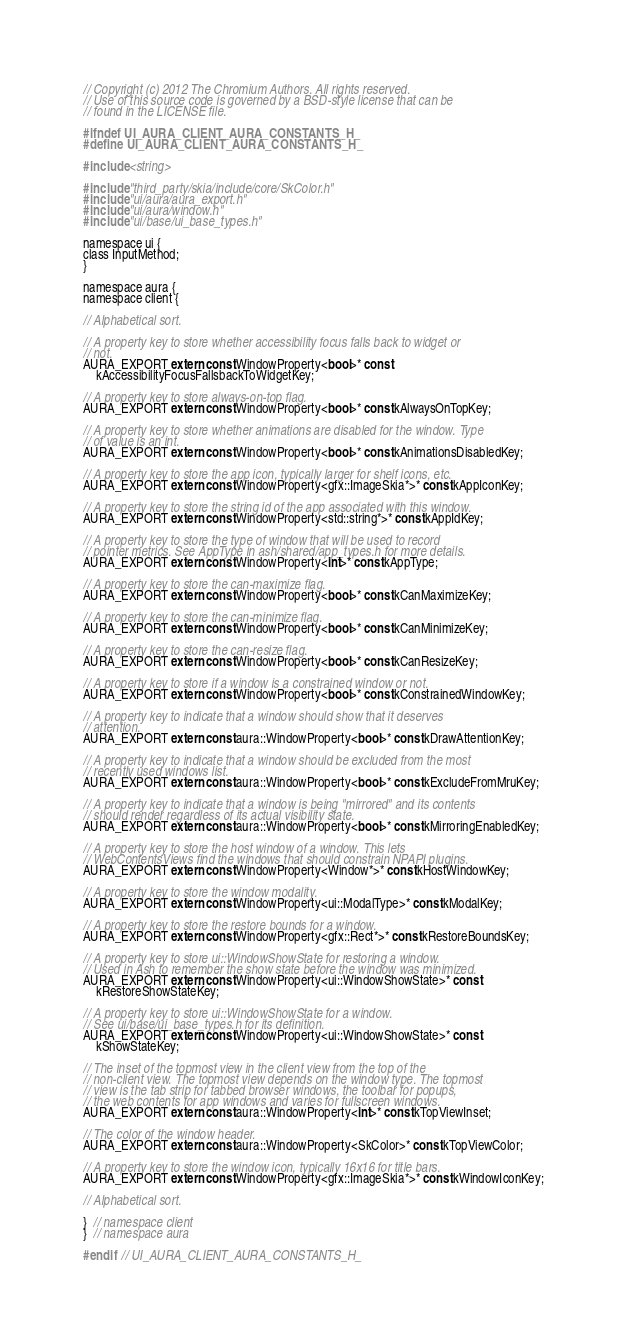<code> <loc_0><loc_0><loc_500><loc_500><_C_>// Copyright (c) 2012 The Chromium Authors. All rights reserved.
// Use of this source code is governed by a BSD-style license that can be
// found in the LICENSE file.

#ifndef UI_AURA_CLIENT_AURA_CONSTANTS_H_
#define UI_AURA_CLIENT_AURA_CONSTANTS_H_

#include <string>

#include "third_party/skia/include/core/SkColor.h"
#include "ui/aura/aura_export.h"
#include "ui/aura/window.h"
#include "ui/base/ui_base_types.h"

namespace ui {
class InputMethod;
}

namespace aura {
namespace client {

// Alphabetical sort.

// A property key to store whether accessibility focus falls back to widget or
// not.
AURA_EXPORT extern const WindowProperty<bool>* const
    kAccessibilityFocusFallsbackToWidgetKey;

// A property key to store always-on-top flag.
AURA_EXPORT extern const WindowProperty<bool>* const kAlwaysOnTopKey;

// A property key to store whether animations are disabled for the window. Type
// of value is an int.
AURA_EXPORT extern const WindowProperty<bool>* const kAnimationsDisabledKey;

// A property key to store the app icon, typically larger for shelf icons, etc.
AURA_EXPORT extern const WindowProperty<gfx::ImageSkia*>* const kAppIconKey;

// A property key to store the string id of the app associated with this window.
AURA_EXPORT extern const WindowProperty<std::string*>* const kAppIdKey;

// A property key to store the type of window that will be used to record
// pointer metrics. See AppType in ash/shared/app_types.h for more details.
AURA_EXPORT extern const WindowProperty<int>* const kAppType;

// A property key to store the can-maximize flag.
AURA_EXPORT extern const WindowProperty<bool>* const kCanMaximizeKey;

// A property key to store the can-minimize flag.
AURA_EXPORT extern const WindowProperty<bool>* const kCanMinimizeKey;

// A property key to store the can-resize flag.
AURA_EXPORT extern const WindowProperty<bool>* const kCanResizeKey;

// A property key to store if a window is a constrained window or not.
AURA_EXPORT extern const WindowProperty<bool>* const kConstrainedWindowKey;

// A property key to indicate that a window should show that it deserves
// attention.
AURA_EXPORT extern const aura::WindowProperty<bool>* const kDrawAttentionKey;

// A property key to indicate that a window should be excluded from the most
// recently used windows list.
AURA_EXPORT extern const aura::WindowProperty<bool>* const kExcludeFromMruKey;

// A property key to indicate that a window is being "mirrored" and its contents
// should render regardless of its actual visibility state.
AURA_EXPORT extern const aura::WindowProperty<bool>* const kMirroringEnabledKey;

// A property key to store the host window of a window. This lets
// WebContentsViews find the windows that should constrain NPAPI plugins.
AURA_EXPORT extern const WindowProperty<Window*>* const kHostWindowKey;

// A property key to store the window modality.
AURA_EXPORT extern const WindowProperty<ui::ModalType>* const kModalKey;

// A property key to store the restore bounds for a window.
AURA_EXPORT extern const WindowProperty<gfx::Rect*>* const kRestoreBoundsKey;

// A property key to store ui::WindowShowState for restoring a window.
// Used in Ash to remember the show state before the window was minimized.
AURA_EXPORT extern const WindowProperty<ui::WindowShowState>* const
    kRestoreShowStateKey;

// A property key to store ui::WindowShowState for a window.
// See ui/base/ui_base_types.h for its definition.
AURA_EXPORT extern const WindowProperty<ui::WindowShowState>* const
    kShowStateKey;

// The inset of the topmost view in the client view from the top of the
// non-client view. The topmost view depends on the window type. The topmost
// view is the tab strip for tabbed browser windows, the toolbar for popups,
// the web contents for app windows and varies for fullscreen windows.
AURA_EXPORT extern const aura::WindowProperty<int>* const kTopViewInset;

// The color of the window header.
AURA_EXPORT extern const aura::WindowProperty<SkColor>* const kTopViewColor;

// A property key to store the window icon, typically 16x16 for title bars.
AURA_EXPORT extern const WindowProperty<gfx::ImageSkia*>* const kWindowIconKey;

// Alphabetical sort.

}  // namespace client
}  // namespace aura

#endif  // UI_AURA_CLIENT_AURA_CONSTANTS_H_
</code> 